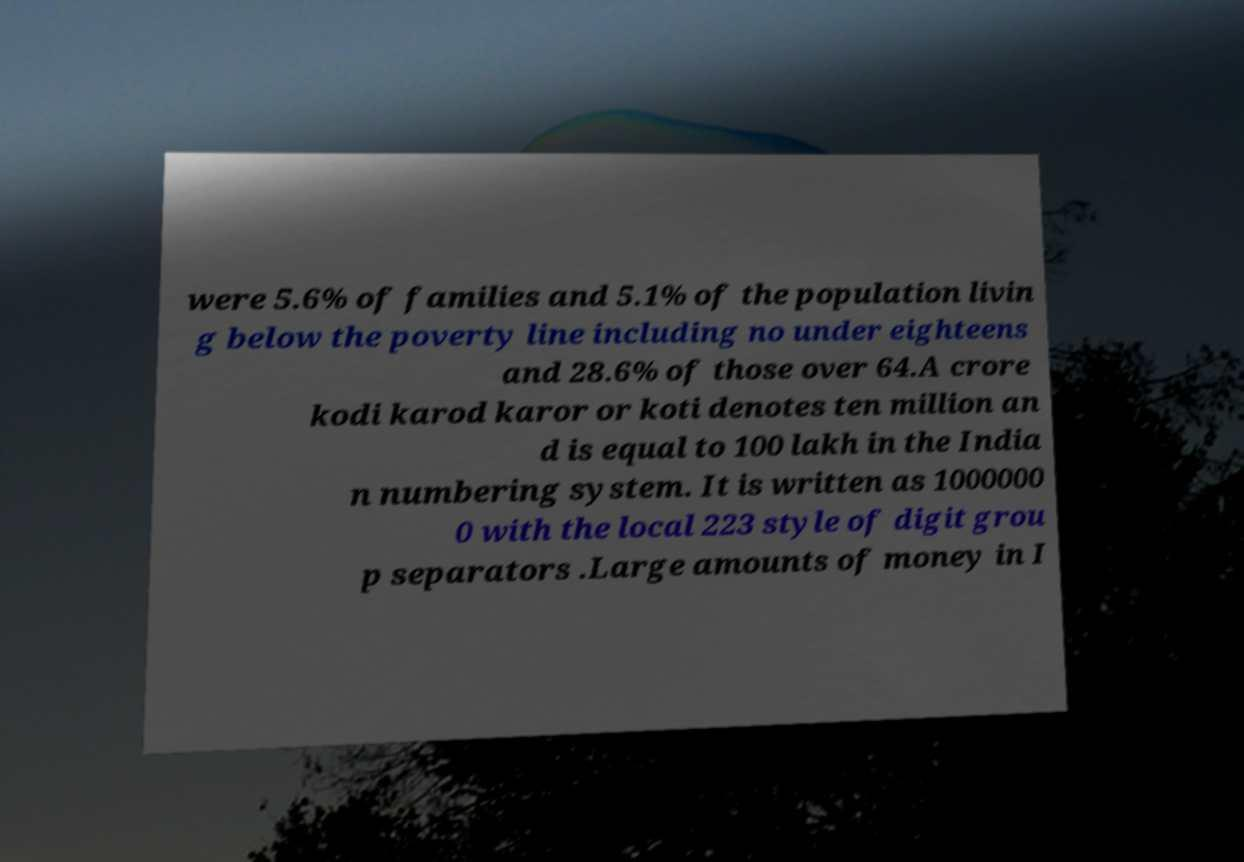I need the written content from this picture converted into text. Can you do that? were 5.6% of families and 5.1% of the population livin g below the poverty line including no under eighteens and 28.6% of those over 64.A crore kodi karod karor or koti denotes ten million an d is equal to 100 lakh in the India n numbering system. It is written as 1000000 0 with the local 223 style of digit grou p separators .Large amounts of money in I 